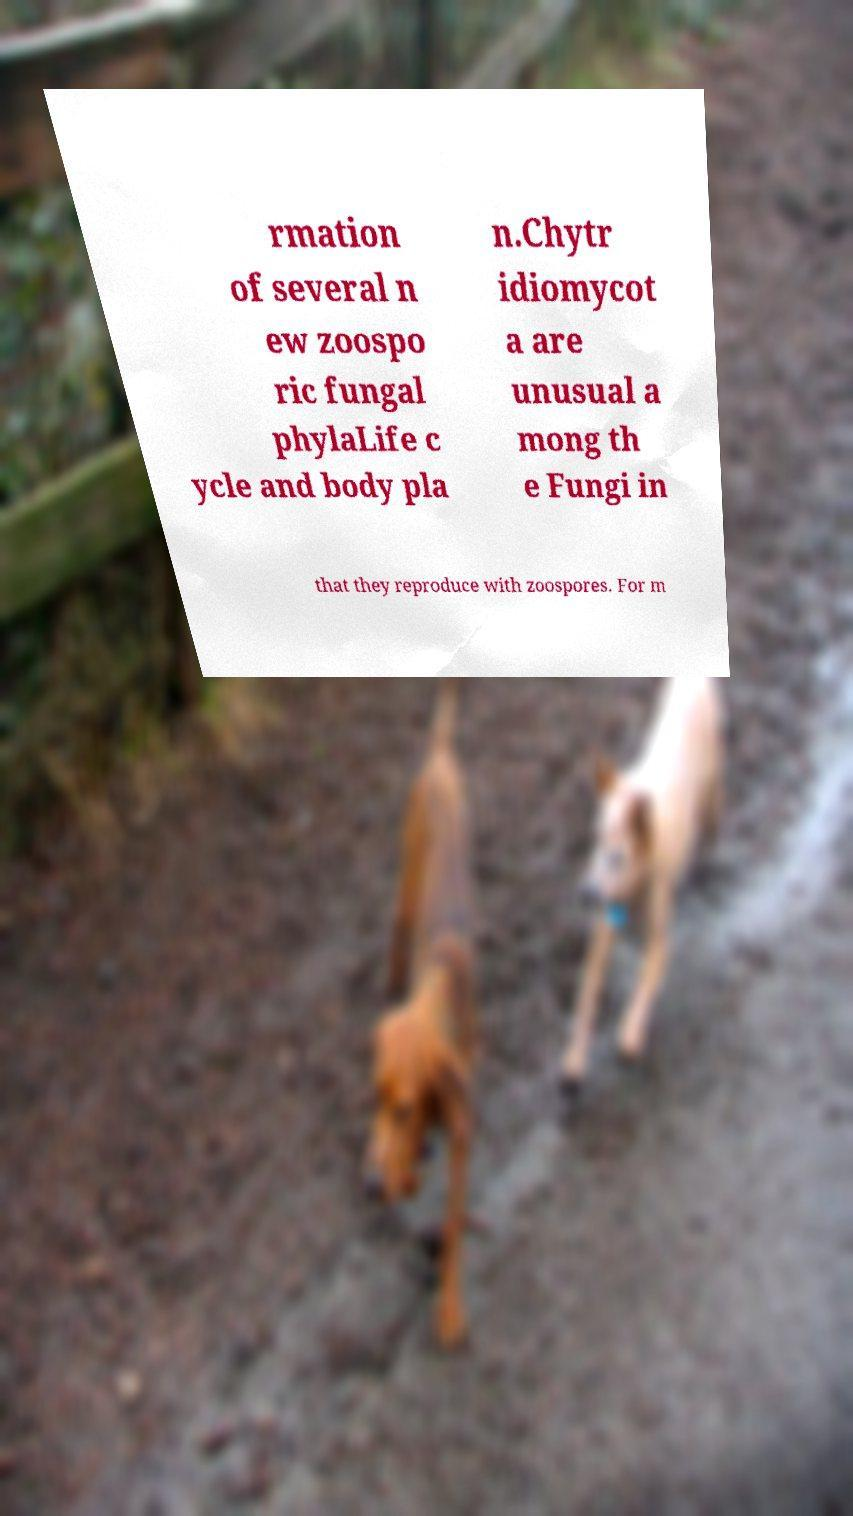I need the written content from this picture converted into text. Can you do that? rmation of several n ew zoospo ric fungal phylaLife c ycle and body pla n.Chytr idiomycot a are unusual a mong th e Fungi in that they reproduce with zoospores. For m 